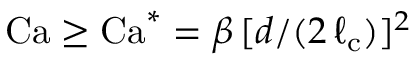<formula> <loc_0><loc_0><loc_500><loc_500>C a \geq C a ^ { * } = \beta \, [ d / ( 2 \, \ell _ { c } ) ] ^ { 2 }</formula> 